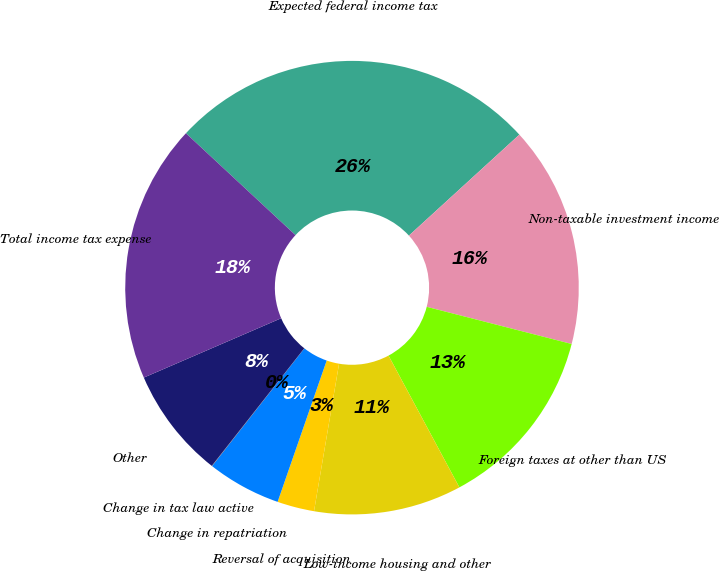Convert chart. <chart><loc_0><loc_0><loc_500><loc_500><pie_chart><fcel>Expected federal income tax<fcel>Non-taxable investment income<fcel>Foreign taxes at other than US<fcel>Low-income housing and other<fcel>Reversal of acquisition<fcel>Change in repatriation<fcel>Change in tax law active<fcel>Other<fcel>Total income tax expense<nl><fcel>26.29%<fcel>15.78%<fcel>13.15%<fcel>10.53%<fcel>2.64%<fcel>5.27%<fcel>0.02%<fcel>7.9%<fcel>18.41%<nl></chart> 